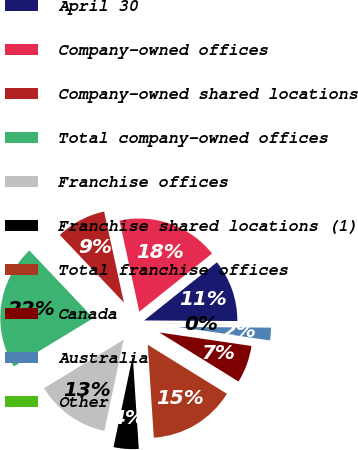Convert chart to OTSL. <chart><loc_0><loc_0><loc_500><loc_500><pie_chart><fcel>April 30<fcel>Company-owned offices<fcel>Company-owned shared locations<fcel>Total company-owned offices<fcel>Franchise offices<fcel>Franchise shared locations (1)<fcel>Total franchise offices<fcel>Canada<fcel>Australia<fcel>Other<nl><fcel>10.83%<fcel>17.68%<fcel>8.67%<fcel>21.62%<fcel>12.99%<fcel>4.35%<fcel>15.14%<fcel>6.51%<fcel>2.19%<fcel>0.03%<nl></chart> 